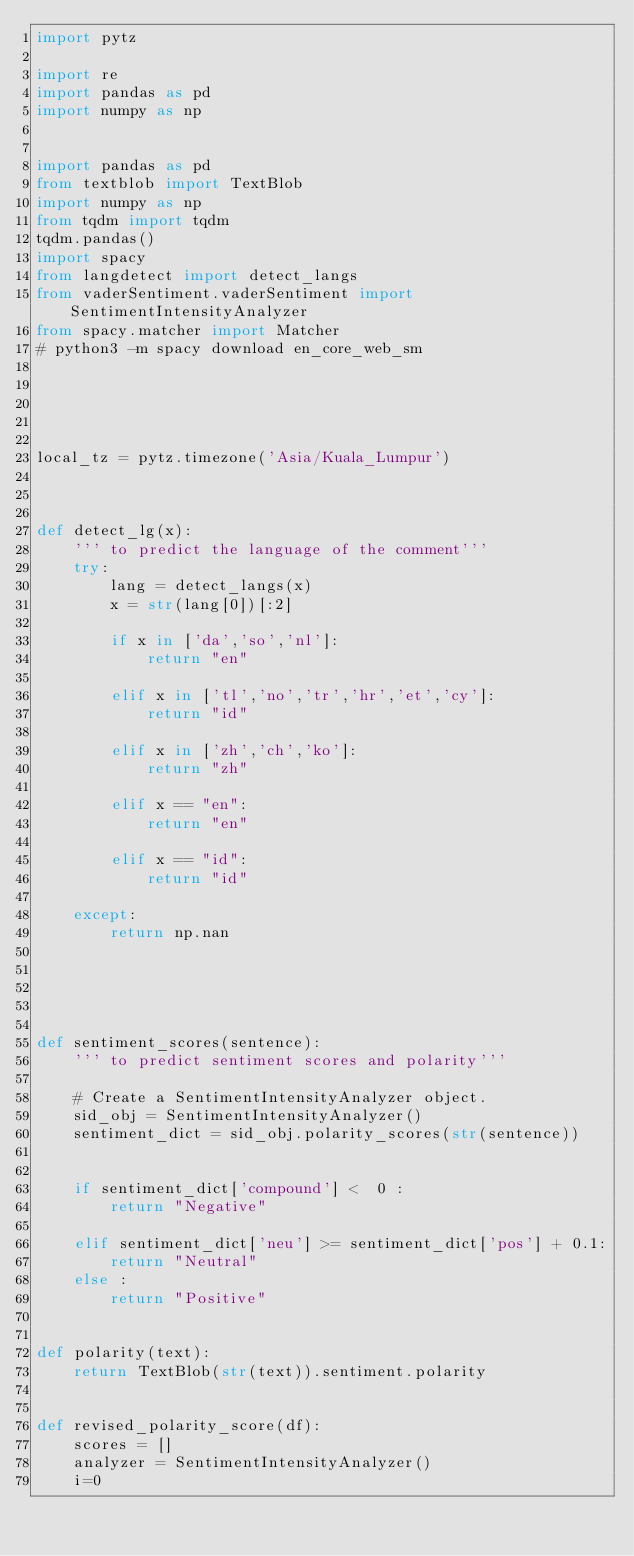Convert code to text. <code><loc_0><loc_0><loc_500><loc_500><_Python_>import pytz

import re
import pandas as pd 
import numpy as np


import pandas as pd
from textblob import TextBlob
import numpy as np
from tqdm import tqdm
tqdm.pandas()
import spacy
from langdetect import detect_langs
from vaderSentiment.vaderSentiment import SentimentIntensityAnalyzer
from spacy.matcher import Matcher
# python3 -m spacy download en_core_web_sm





local_tz = pytz.timezone('Asia/Kuala_Lumpur')



def detect_lg(x):
    ''' to predict the language of the comment'''
    try:
        lang = detect_langs(x)
        x = str(lang[0])[:2]

        if x in ['da','so','nl']:
            return "en"

        elif x in ['tl','no','tr','hr','et','cy']:
            return "id"

        elif x in ['zh','ch','ko']:
            return "zh"

        elif x == "en":
            return "en"
        
        elif x == "id":
            return "id"

    except:
        return np.nan

    



def sentiment_scores(sentence):
    ''' to predict sentiment scores and polarity'''

    # Create a SentimentIntensityAnalyzer object.
    sid_obj = SentimentIntensityAnalyzer()
    sentiment_dict = sid_obj.polarity_scores(str(sentence))
    
    
    if sentiment_dict['compound'] <  0 :
        return "Negative"
    
    elif sentiment_dict['neu'] >= sentiment_dict['pos'] + 0.1:
        return "Neutral"
    else :
        return "Positive"


def polarity(text):
    return TextBlob(str(text)).sentiment.polarity


def revised_polarity_score(df):
    scores = []
    analyzer = SentimentIntensityAnalyzer()
    i=0</code> 